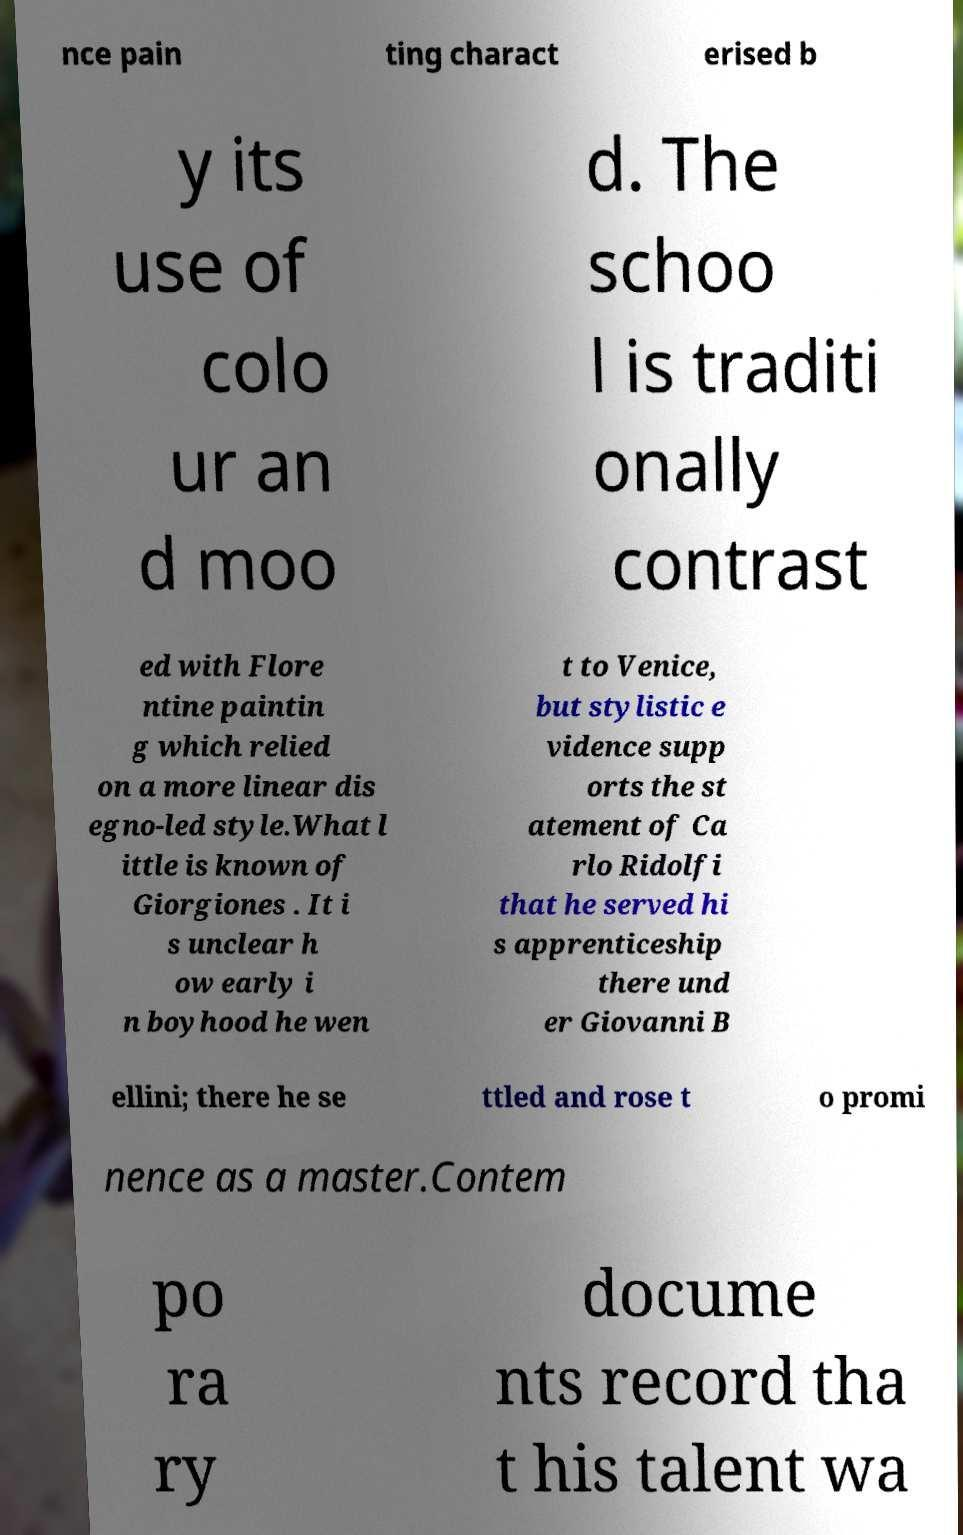Could you extract and type out the text from this image? nce pain ting charact erised b y its use of colo ur an d moo d. The schoo l is traditi onally contrast ed with Flore ntine paintin g which relied on a more linear dis egno-led style.What l ittle is known of Giorgiones . It i s unclear h ow early i n boyhood he wen t to Venice, but stylistic e vidence supp orts the st atement of Ca rlo Ridolfi that he served hi s apprenticeship there und er Giovanni B ellini; there he se ttled and rose t o promi nence as a master.Contem po ra ry docume nts record tha t his talent wa 